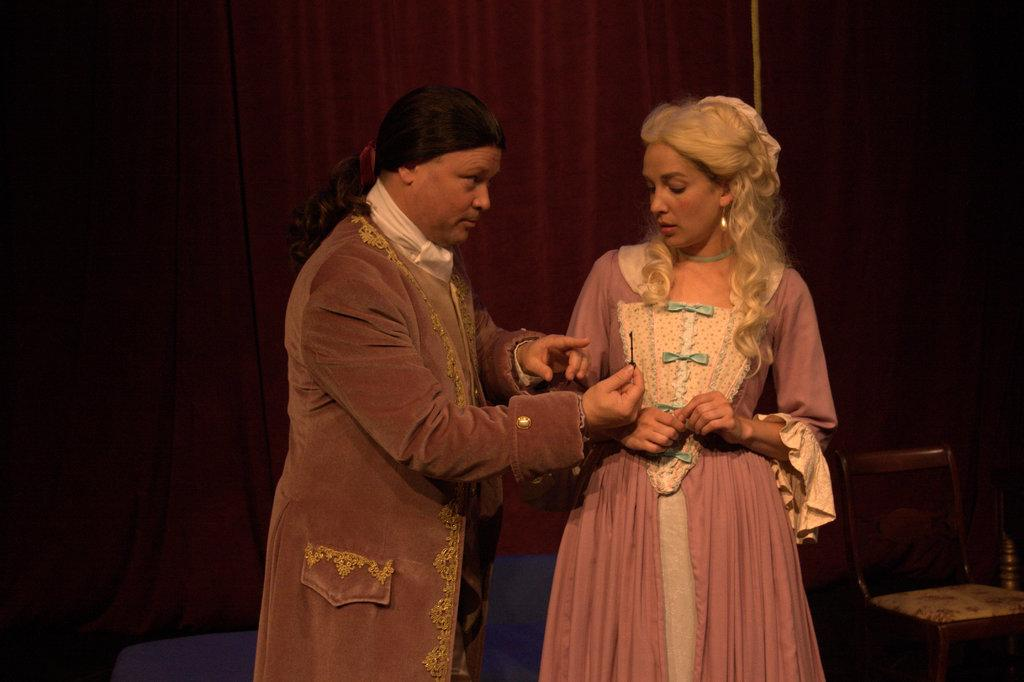How many people are in the image? There are two persons in the image. What are the persons doing in the image? The persons are standing. What can be observed about the clothing of the persons in the image? The persons are wearing colorful clothes. Can you describe any furniture in the image? There is a chair in the bottom right of the image. What is the grade of the attempt made by the persons in the image? There is no indication of an attempt or grade in the image, as it simply shows two persons standing and wearing colorful clothes. 